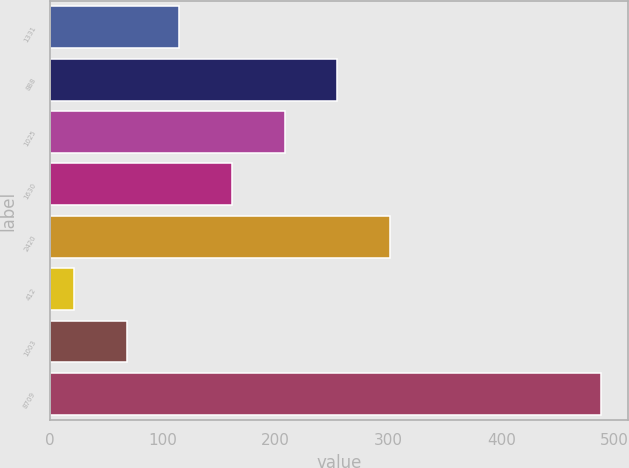Convert chart to OTSL. <chart><loc_0><loc_0><loc_500><loc_500><bar_chart><fcel>1331<fcel>888<fcel>1025<fcel>1630<fcel>2420<fcel>412<fcel>1003<fcel>8709<nl><fcel>114.68<fcel>254.6<fcel>207.96<fcel>161.32<fcel>301.24<fcel>21.4<fcel>68.04<fcel>487.8<nl></chart> 